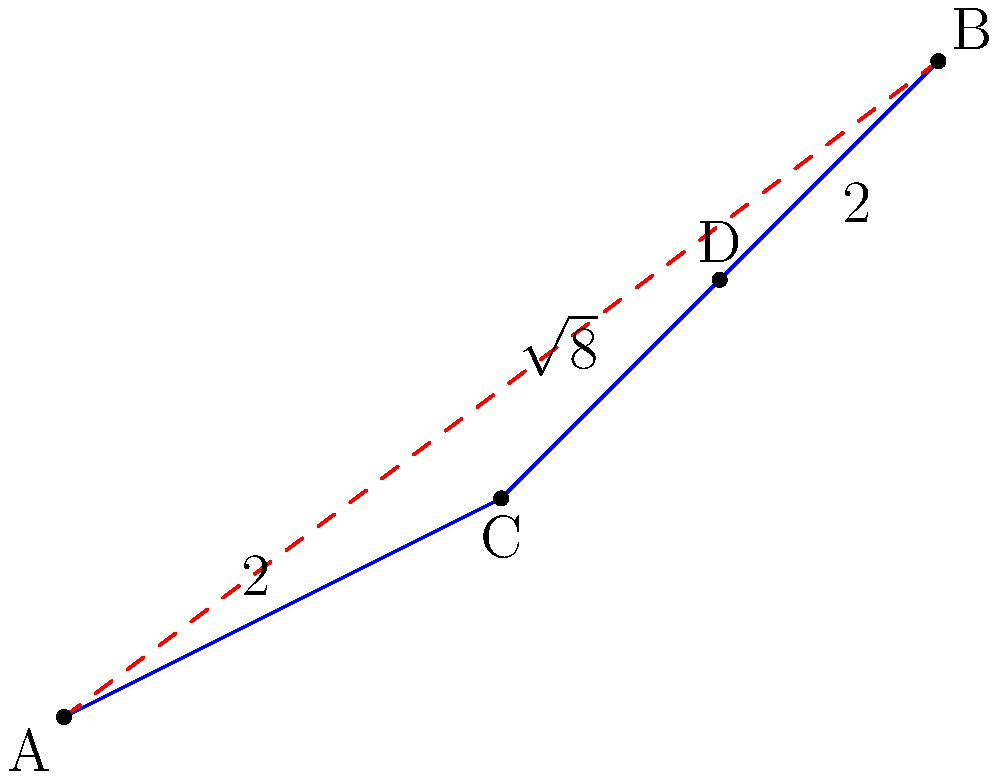In a complex network optimization problem, you need to find the shortest path between points A and B. The direct path (shown in red) is blocked. The only available route is through points C and D (shown in blue). Given that AC = 2, CD = $\sqrt{8}$, and DB = 2, what is the total length of the shortest path from A to B through C and D? To solve this problem, we'll follow these steps:

1) First, we need to calculate the length of the path A-C-D-B.

2) The path consists of three segments: AC, CD, and DB.

3) We're given the lengths of these segments:
   AC = 2
   CD = $\sqrt{8}$
   DB = 2

4) To find the total length, we simply add these segments:

   Total length = AC + CD + DB
                = 2 + $\sqrt{8}$ + 2
                = 4 + $\sqrt{8}$

5) We can simplify $\sqrt{8}$:
   $\sqrt{8}$ = $\sqrt{4 * 2}$ = $\sqrt{4} * \sqrt{2}$ = 2$\sqrt{2}$

6) Substituting this back:
   Total length = 4 + 2$\sqrt{2}$

Therefore, the shortest path from A to B through C and D is 4 + 2$\sqrt{2}$ units long.
Answer: 4 + 2$\sqrt{2}$ 